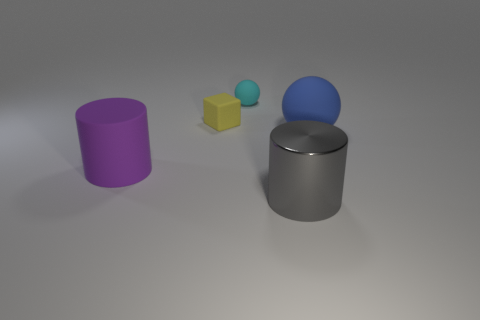Subtract all purple cylinders. How many cylinders are left? 1 Add 5 blue cylinders. How many objects exist? 10 Subtract 1 cylinders. How many cylinders are left? 1 Add 4 big brown cylinders. How many big brown cylinders exist? 4 Subtract 0 brown cubes. How many objects are left? 5 Subtract all blocks. How many objects are left? 4 Subtract all yellow balls. Subtract all cyan cubes. How many balls are left? 2 Subtract all large cyan rubber blocks. Subtract all metal things. How many objects are left? 4 Add 3 small cyan matte objects. How many small cyan matte objects are left? 4 